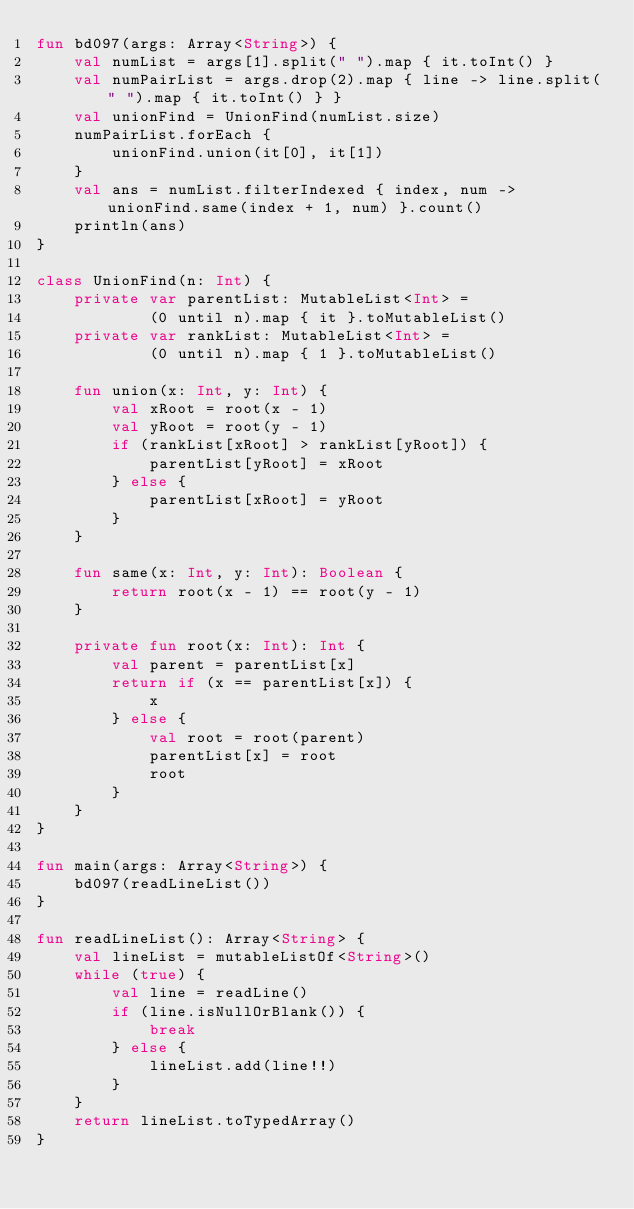<code> <loc_0><loc_0><loc_500><loc_500><_Kotlin_>fun bd097(args: Array<String>) {
    val numList = args[1].split(" ").map { it.toInt() }
    val numPairList = args.drop(2).map { line -> line.split(" ").map { it.toInt() } }
    val unionFind = UnionFind(numList.size)
    numPairList.forEach {
        unionFind.union(it[0], it[1])
    }
    val ans = numList.filterIndexed { index, num -> unionFind.same(index + 1, num) }.count()
    println(ans)
}

class UnionFind(n: Int) {
    private var parentList: MutableList<Int> =
            (0 until n).map { it }.toMutableList()
    private var rankList: MutableList<Int> =
            (0 until n).map { 1 }.toMutableList()

    fun union(x: Int, y: Int) {
        val xRoot = root(x - 1)
        val yRoot = root(y - 1)
        if (rankList[xRoot] > rankList[yRoot]) {
            parentList[yRoot] = xRoot
        } else {
            parentList[xRoot] = yRoot
        }
    }

    fun same(x: Int, y: Int): Boolean {
        return root(x - 1) == root(y - 1)
    }

    private fun root(x: Int): Int {
        val parent = parentList[x]
        return if (x == parentList[x]) {
            x
        } else {
            val root = root(parent)
            parentList[x] = root
            root
        }
    }
}

fun main(args: Array<String>) {
    bd097(readLineList())
}

fun readLineList(): Array<String> {
    val lineList = mutableListOf<String>()
    while (true) {
        val line = readLine()
        if (line.isNullOrBlank()) {
            break
        } else {
            lineList.add(line!!)
        }
    }
    return lineList.toTypedArray()
}</code> 